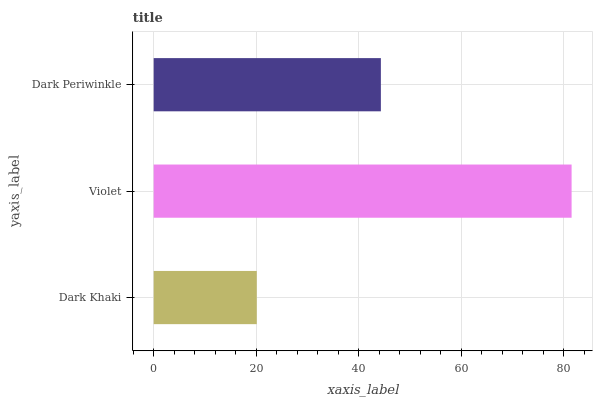Is Dark Khaki the minimum?
Answer yes or no. Yes. Is Violet the maximum?
Answer yes or no. Yes. Is Dark Periwinkle the minimum?
Answer yes or no. No. Is Dark Periwinkle the maximum?
Answer yes or no. No. Is Violet greater than Dark Periwinkle?
Answer yes or no. Yes. Is Dark Periwinkle less than Violet?
Answer yes or no. Yes. Is Dark Periwinkle greater than Violet?
Answer yes or no. No. Is Violet less than Dark Periwinkle?
Answer yes or no. No. Is Dark Periwinkle the high median?
Answer yes or no. Yes. Is Dark Periwinkle the low median?
Answer yes or no. Yes. Is Dark Khaki the high median?
Answer yes or no. No. Is Violet the low median?
Answer yes or no. No. 